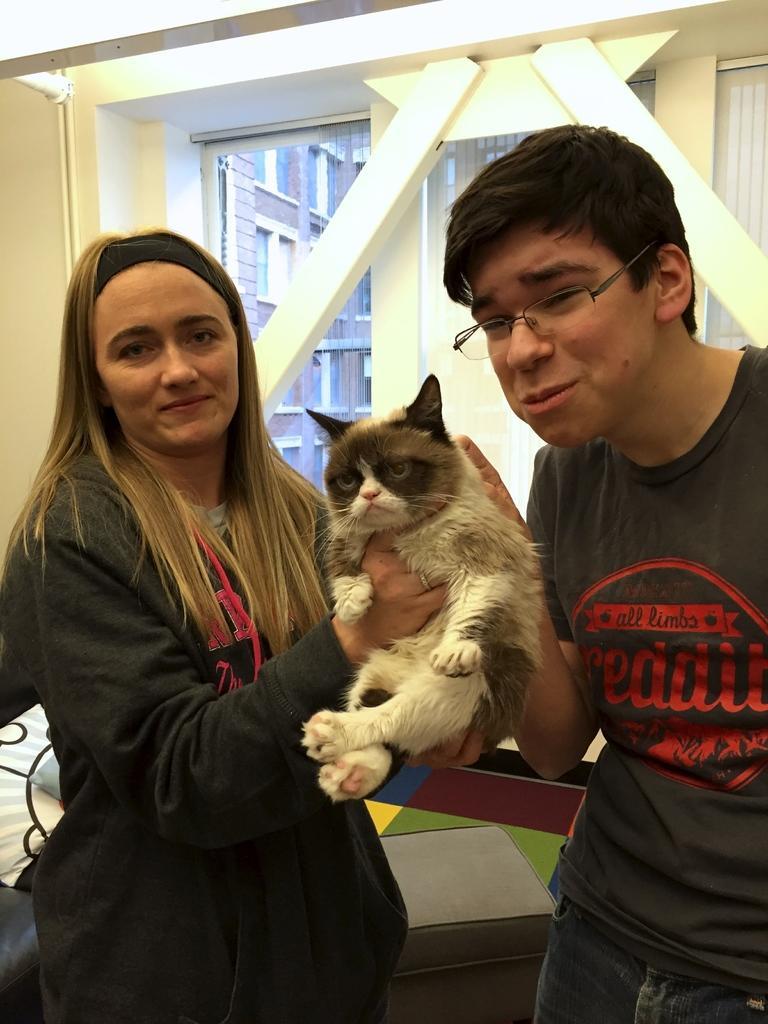Describe this image in one or two sentences. In this picture there is a woman and a man holding a cat and in the backdrop there is a window, wall, lights, windows and there are some buildings 